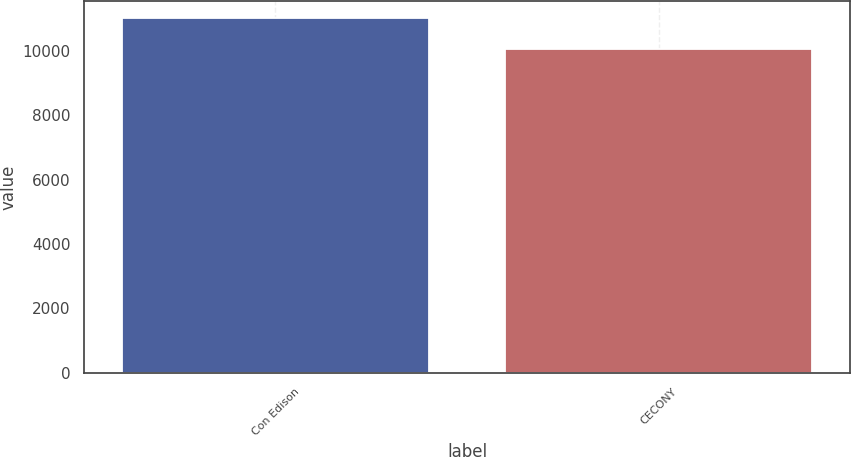<chart> <loc_0><loc_0><loc_500><loc_500><bar_chart><fcel>Con Edison<fcel>CECONY<nl><fcel>11009<fcel>10052<nl></chart> 